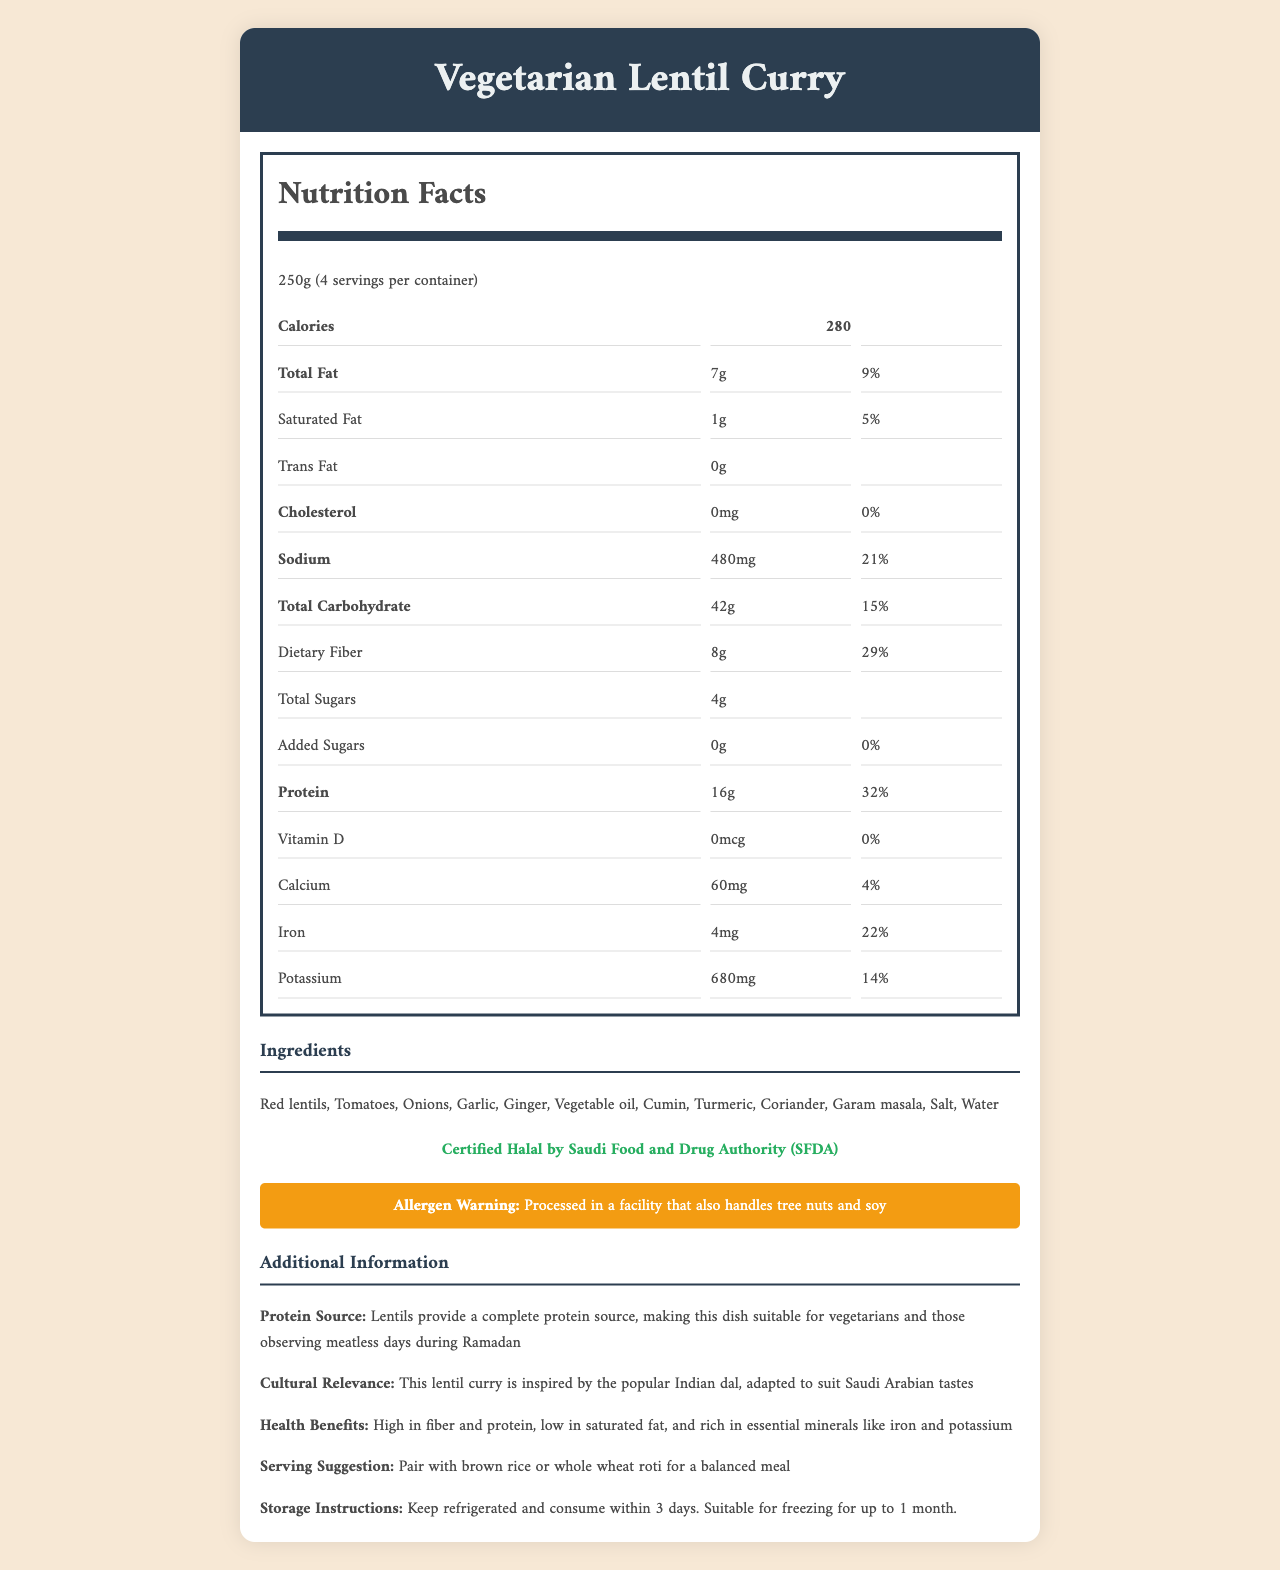who certified the Vegetarian Lentil Curry as Halal? The document specifies that the Halal certification is provided by the Saudi Food and Drug Authority (SFDA).
Answer: Certified Halal by Saudi Food and Drug Authority (SFDA) what is the serving size for the Vegetarian Lentil Curry? The serving size is listed as 250 grams per serving.
Answer: 250g how many calories are there per serving? The Nutrition Facts label states that there are 280 calories per serving.
Answer: 280 calories what is the sodium content per serving? The sodium content per serving is given as 480 milligrams.
Answer: 480mg how much protein does one serving of the Vegetarian Lentil Curry provide? One serving of the curry provides 16 grams of protein.
Answer: 16g where is this dish inspired from? The document mentions that the dish is inspired by the popular Indian dal.
Answer: Indian dal which ingredient is not a part of the Vegetarian Lentil Curry? A. Red lentils B. Potatoes C. Tomatoes D. Garlic The ingredient list includes red lentils, tomatoes, onions, garlic, ginger, vegetable oil, cumin, turmeric, coriander, garam masala, salt, and water; it does not include potatoes.
Answer: B. Potatoes how much dietary fiber does the Vegetarian Lentil Curry contain per serving? The Nutrition Facts label shows 8 grams of dietary fiber per serving.
Answer: 8g what percentage of the daily value of iron is provided by one serving? One serving provides 22% of the daily value for iron.
Answer: 22% how many servings are there per container? A. 2 B. 4 C. 6 The document specifies that there are 4 servings per container.
Answer: B. 4 is there any trans fat in the Vegetarian Lentil Curry? The document states that there are 0 grams of trans fat.
Answer: No what are the additional protein sources mentioned in the document? The additional information section mentions that lentils provide a complete protein source.
Answer: Lentils provide a complete protein source for how long can the Vegetarian Lentil Curry be stored in a refrigerator? The storage instructions state that the curry should be kept refrigerated and consumed within 3 days.
Answer: 3 days what is the main idea of the document? The document's primary purpose is to present the nutritional breakdown, ingredients, allergen information, and various benefits, including Halal certification and cultural relevance, of the Vegetarian Lentil Curry.
Answer: The document provides the nutritional information, ingredient list, and other relevant details about a Vegetarian Lentil Curry, highlighting its high protein content and other health benefits. what is the cholesterol level in the Vegetarian Lentil Curry? The document indicates that there is no cholesterol in the curry.
Answer: 0mg can you determine the price of the Vegetarian Lentil Curry from the document? The document does not provide any information about the price of the Vegetarian Lentil Curry.
Answer: Not enough information 